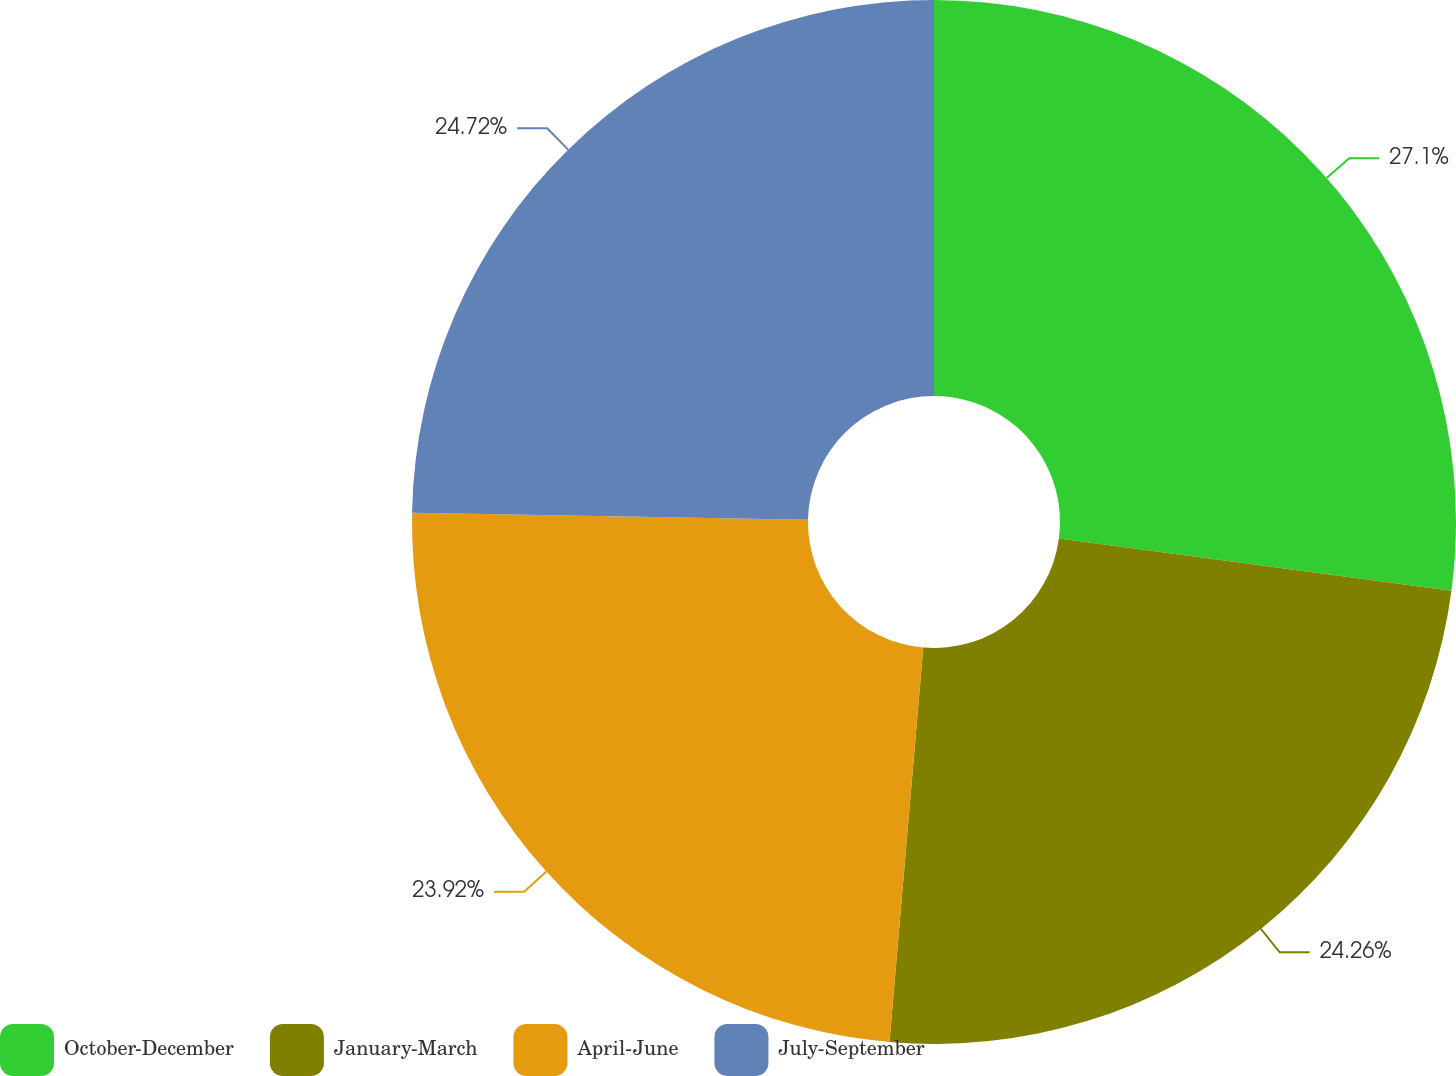<chart> <loc_0><loc_0><loc_500><loc_500><pie_chart><fcel>October-December<fcel>January-March<fcel>April-June<fcel>July-September<nl><fcel>27.1%<fcel>24.26%<fcel>23.92%<fcel>24.72%<nl></chart> 